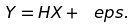Convert formula to latex. <formula><loc_0><loc_0><loc_500><loc_500>Y = H X + \ e p s .</formula> 